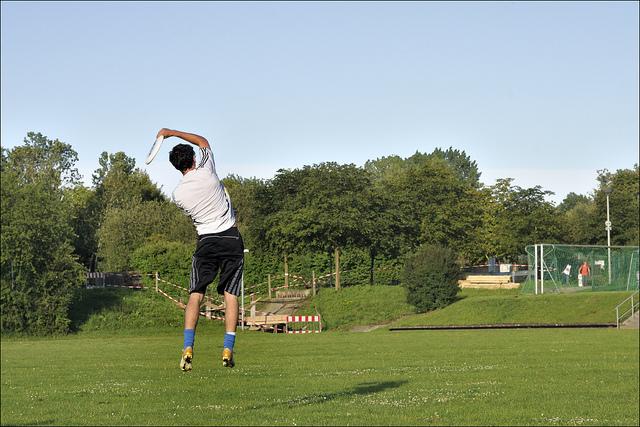Where is the safety net?
Quick response, please. On other side of field. What is the man in the blue socks holding in his right hand?
Be succinct. Frisbee. Is the man playing golf?
Quick response, please. No. 